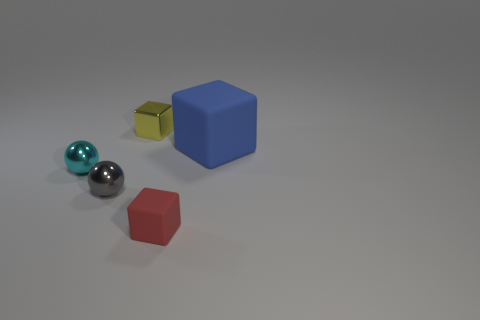Add 1 cyan shiny things. How many objects exist? 6 Subtract all balls. How many objects are left? 3 Add 2 purple metal balls. How many purple metal balls exist? 2 Subtract 0 yellow spheres. How many objects are left? 5 Subtract all balls. Subtract all large objects. How many objects are left? 2 Add 4 metal spheres. How many metal spheres are left? 6 